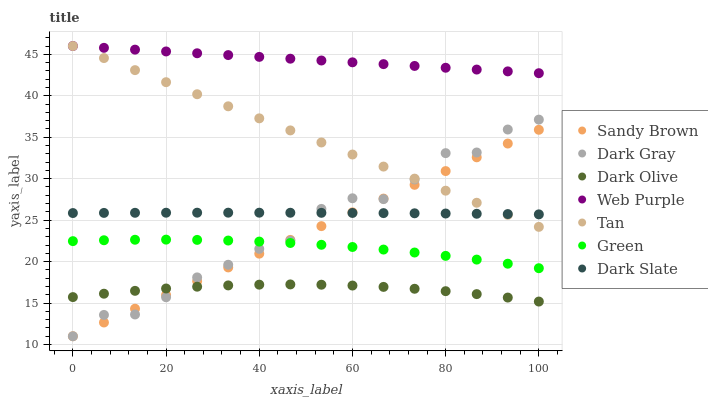Does Dark Olive have the minimum area under the curve?
Answer yes or no. Yes. Does Web Purple have the maximum area under the curve?
Answer yes or no. Yes. Does Dark Gray have the minimum area under the curve?
Answer yes or no. No. Does Dark Gray have the maximum area under the curve?
Answer yes or no. No. Is Web Purple the smoothest?
Answer yes or no. Yes. Is Dark Gray the roughest?
Answer yes or no. Yes. Is Dark Slate the smoothest?
Answer yes or no. No. Is Dark Slate the roughest?
Answer yes or no. No. Does Dark Gray have the lowest value?
Answer yes or no. Yes. Does Dark Slate have the lowest value?
Answer yes or no. No. Does Tan have the highest value?
Answer yes or no. Yes. Does Dark Gray have the highest value?
Answer yes or no. No. Is Dark Olive less than Tan?
Answer yes or no. Yes. Is Dark Slate greater than Dark Olive?
Answer yes or no. Yes. Does Green intersect Sandy Brown?
Answer yes or no. Yes. Is Green less than Sandy Brown?
Answer yes or no. No. Is Green greater than Sandy Brown?
Answer yes or no. No. Does Dark Olive intersect Tan?
Answer yes or no. No. 